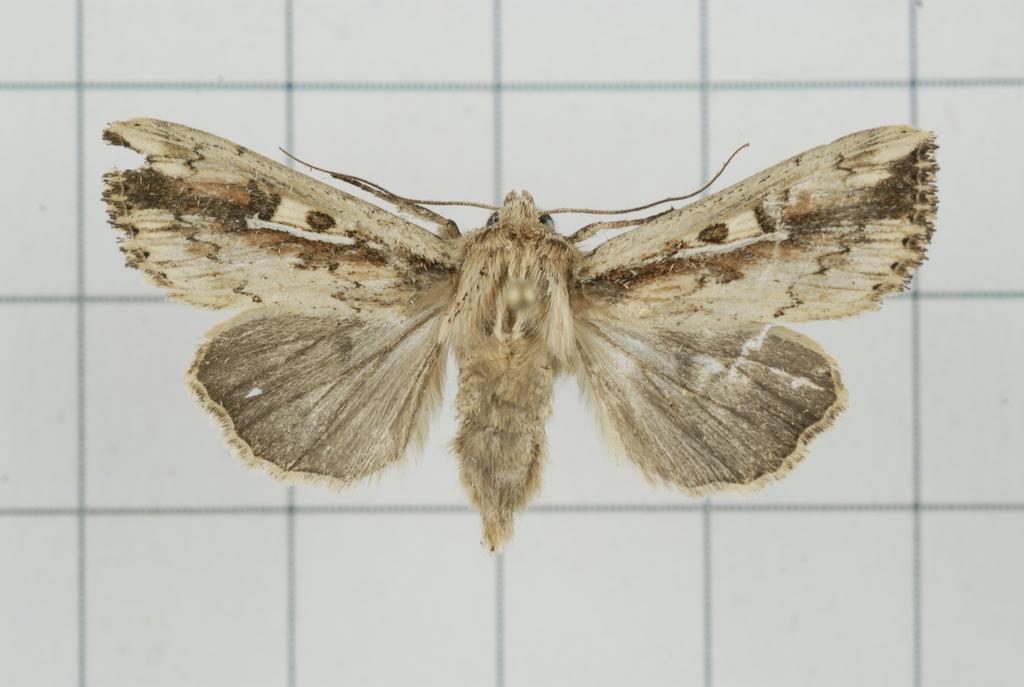In one or two sentences, can you explain what this image depicts? As we can see in the image there is a cream colour butterfly and at the background there are white colour tiles. 